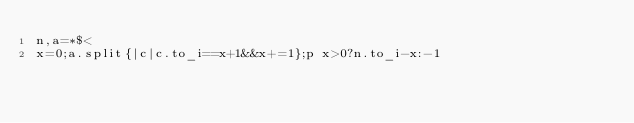<code> <loc_0><loc_0><loc_500><loc_500><_Ruby_>n,a=*$<
x=0;a.split{|c|c.to_i==x+1&&x+=1};p x>0?n.to_i-x:-1</code> 